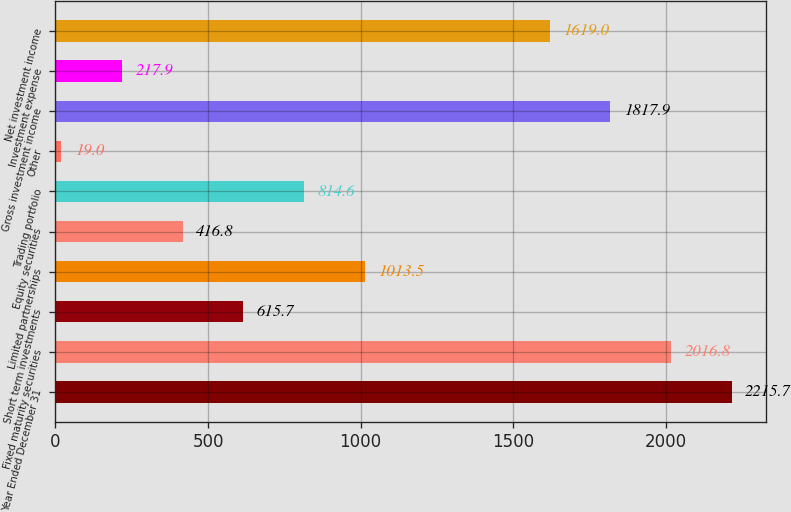Convert chart to OTSL. <chart><loc_0><loc_0><loc_500><loc_500><bar_chart><fcel>Year Ended December 31<fcel>Fixed maturity securities<fcel>Short term investments<fcel>Limited partnerships<fcel>Equity securities<fcel>Trading portfolio<fcel>Other<fcel>Gross investment income<fcel>Investment expense<fcel>Net investment income<nl><fcel>2215.7<fcel>2016.8<fcel>615.7<fcel>1013.5<fcel>416.8<fcel>814.6<fcel>19<fcel>1817.9<fcel>217.9<fcel>1619<nl></chart> 